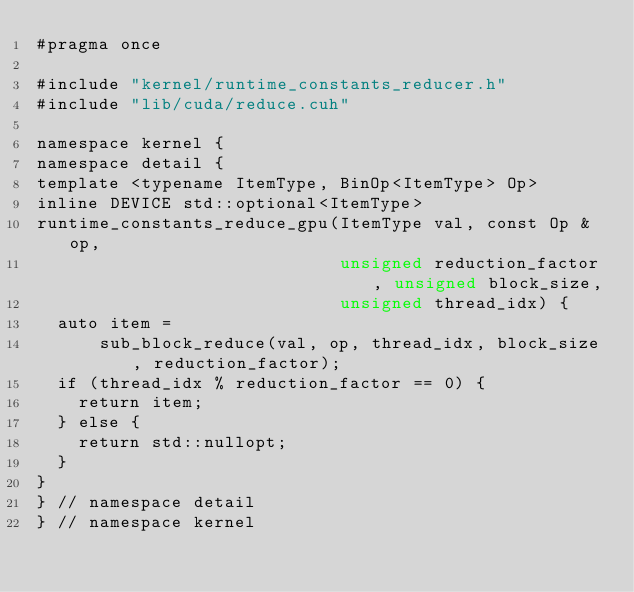Convert code to text. <code><loc_0><loc_0><loc_500><loc_500><_Cuda_>#pragma once

#include "kernel/runtime_constants_reducer.h"
#include "lib/cuda/reduce.cuh"

namespace kernel {
namespace detail {
template <typename ItemType, BinOp<ItemType> Op>
inline DEVICE std::optional<ItemType>
runtime_constants_reduce_gpu(ItemType val, const Op &op,
                             unsigned reduction_factor, unsigned block_size,
                             unsigned thread_idx) {
  auto item =
      sub_block_reduce(val, op, thread_idx, block_size, reduction_factor);
  if (thread_idx % reduction_factor == 0) {
    return item;
  } else {
    return std::nullopt;
  }
}
} // namespace detail
} // namespace kernel
</code> 